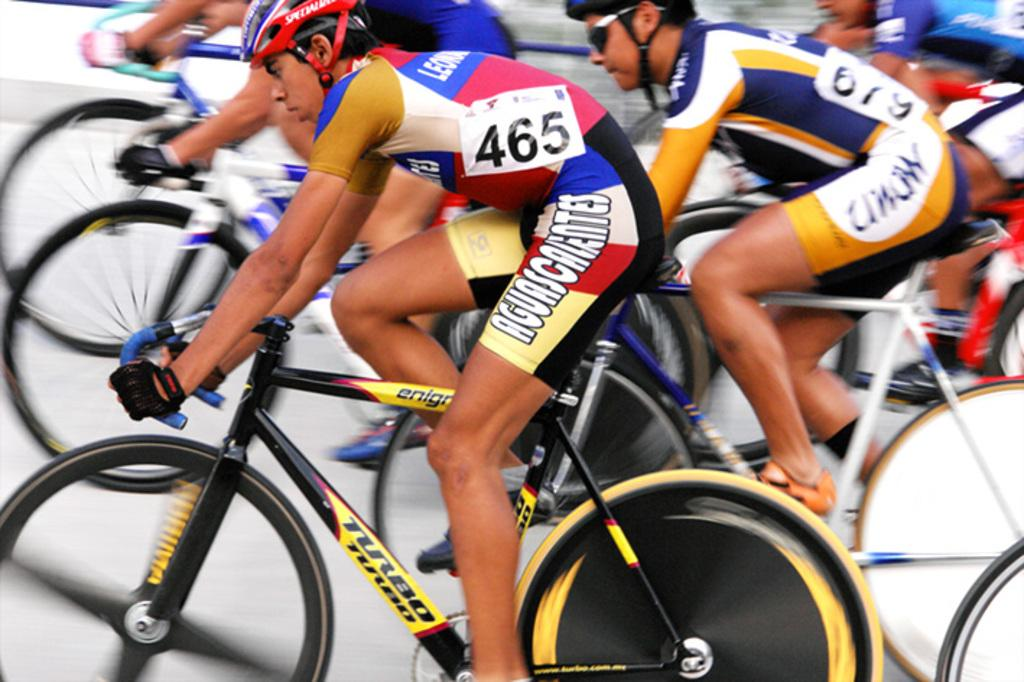What are the people in the image doing? The people in the image are sitting on bicycles. What is the color of the surface on which the bicycles are placed? The bicycles are on a white color surface. What safety equipment are the people wearing? The people are wearing helmets. What type of clothing are the people wearing? The people are wearing clothes. What additional accessories are the people wearing? The people are wearing hand gloves. How many owls can be seen sitting on the bicycles in the image? There are no owls present in the image; the people are sitting on bicycles. What type of dogs are visible in the image? There are no dogs present in the image; the people are sitting on bicycles. 